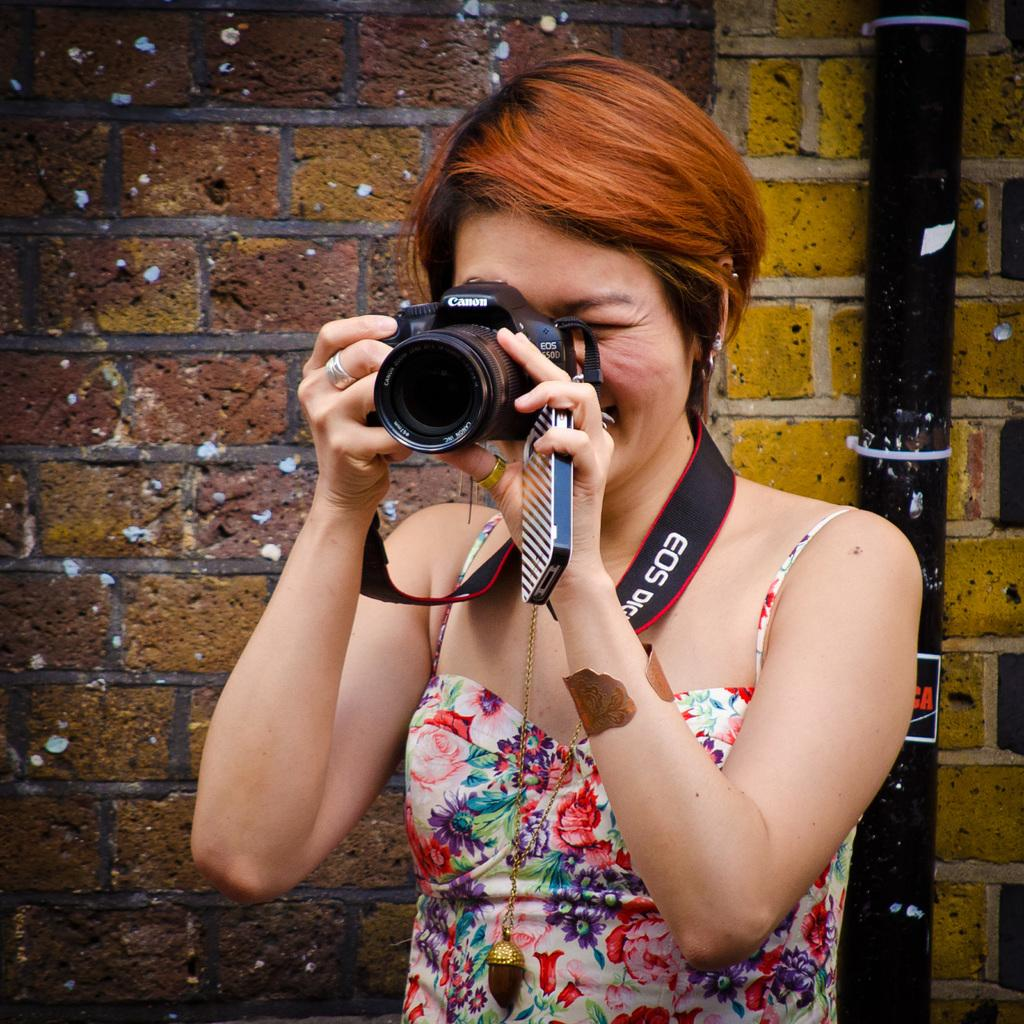What is the woman in the image holding? The woman is holding a camera and a mobile phone. What is the woman doing with the camera? The woman is taking a picture. What can be seen in the background of the image? There is a pipe and a brick wall in the background of the image. How is the woman wearing her belt? The woman is wearing a belt around her neck. What type of stocking is the governor wearing for comfort in the image? There is no governor or stocking present in the image. 